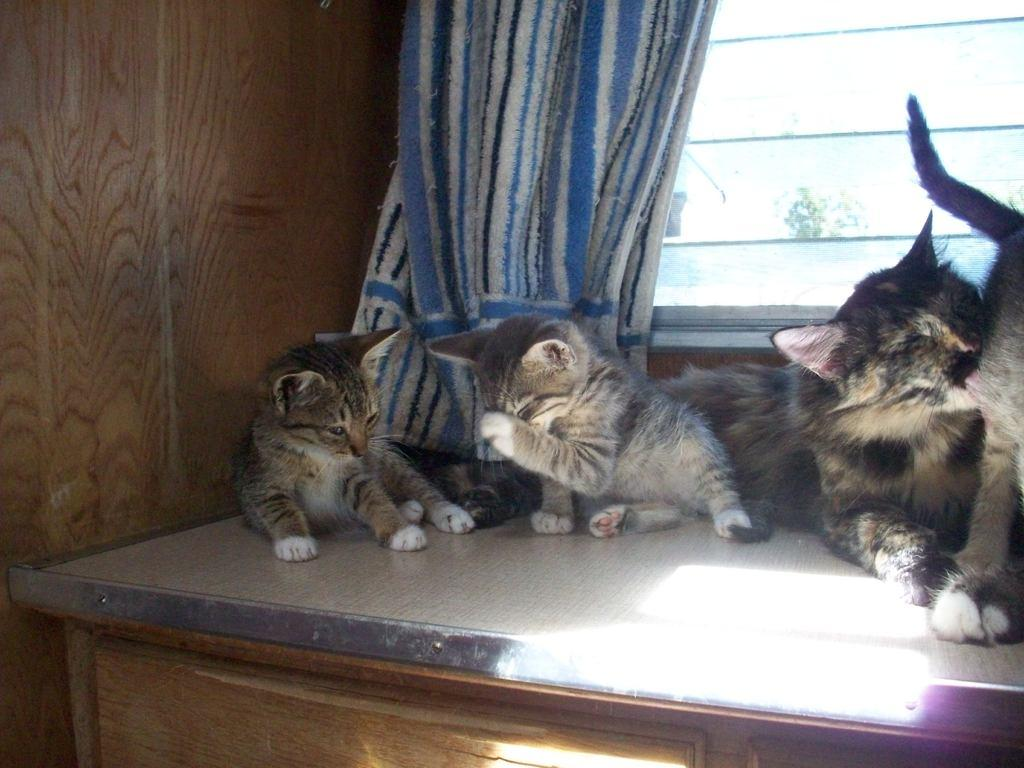What type of animals are in the image? There are cats in the image. Where are the cats located? The cats are on a wooden object. What can be seen in the background of the image? There is a curtain, a window, and a wooden wall in the background of the image. What theory does the sack in the image support? There is no sack present in the image, so it cannot support any theory. 